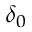<formula> <loc_0><loc_0><loc_500><loc_500>\delta _ { 0 }</formula> 